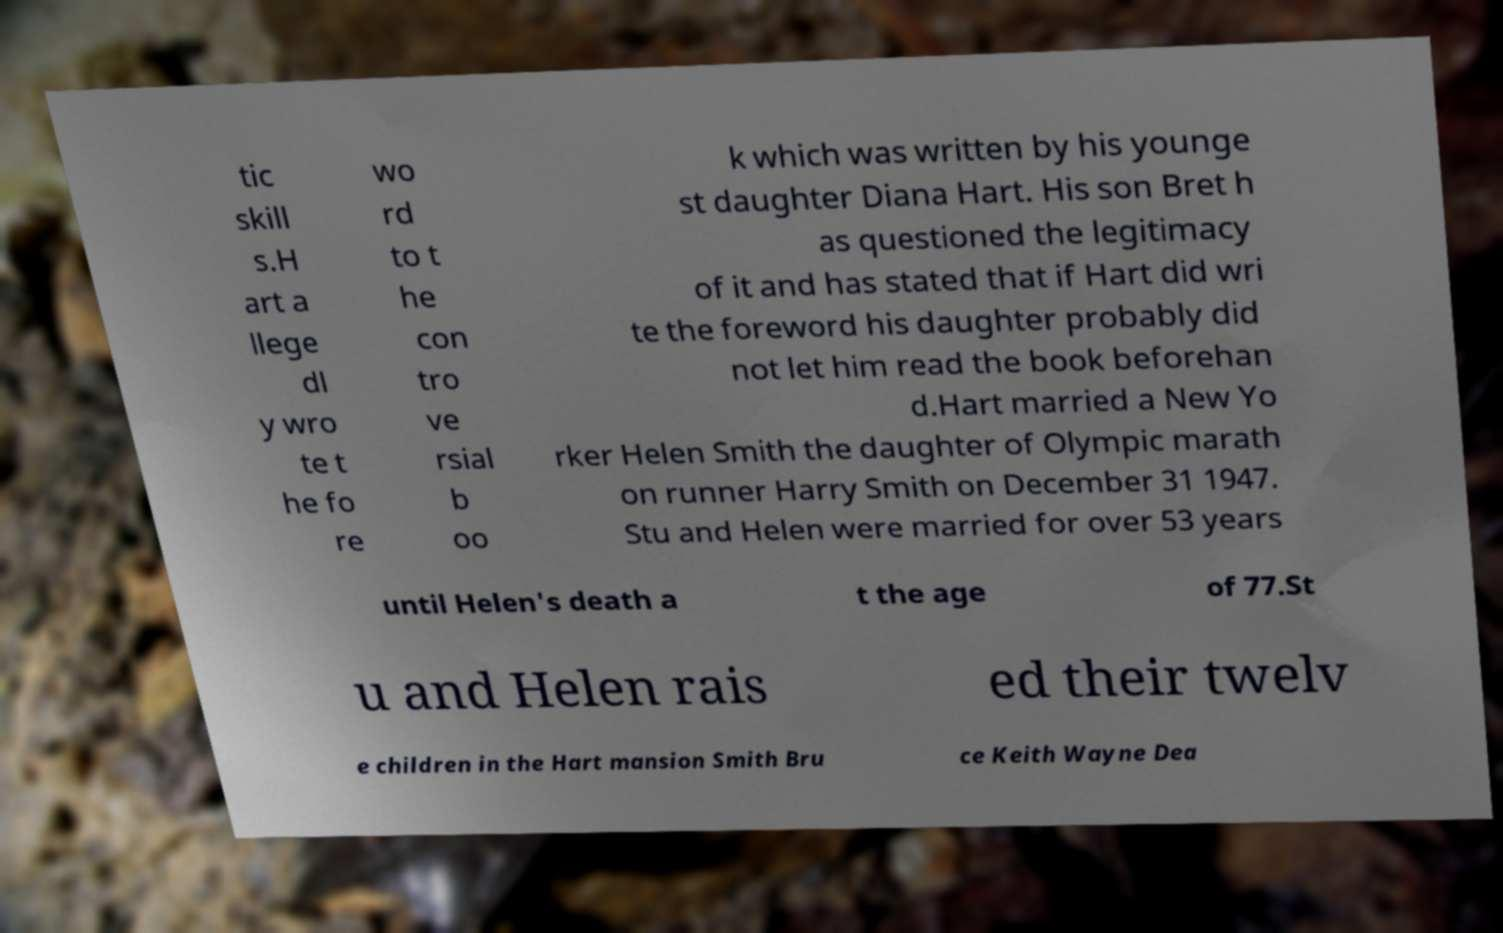I need the written content from this picture converted into text. Can you do that? tic skill s.H art a llege dl y wro te t he fo re wo rd to t he con tro ve rsial b oo k which was written by his younge st daughter Diana Hart. His son Bret h as questioned the legitimacy of it and has stated that if Hart did wri te the foreword his daughter probably did not let him read the book beforehan d.Hart married a New Yo rker Helen Smith the daughter of Olympic marath on runner Harry Smith on December 31 1947. Stu and Helen were married for over 53 years until Helen's death a t the age of 77.St u and Helen rais ed their twelv e children in the Hart mansion Smith Bru ce Keith Wayne Dea 